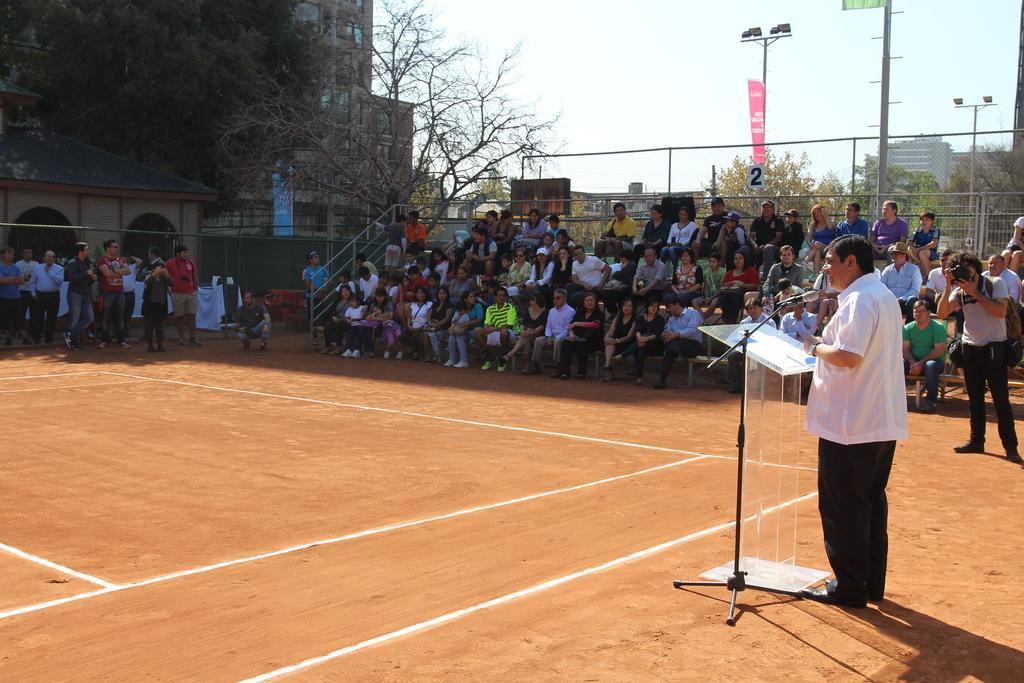How would you summarize this image in a sentence or two? In this picture we can see a person standing in front of the podium. There is a microphone on the microphone stand. We can see a few people sitting on the benches. There are some people standing on the ground. We can see street lights, some text and a few things on the objects. There is some fencing, trees, buildings and other objects. We can see the sky. 